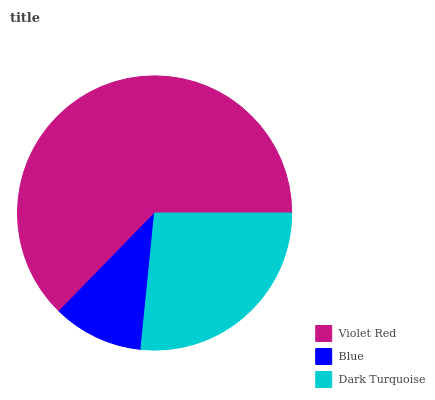Is Blue the minimum?
Answer yes or no. Yes. Is Violet Red the maximum?
Answer yes or no. Yes. Is Dark Turquoise the minimum?
Answer yes or no. No. Is Dark Turquoise the maximum?
Answer yes or no. No. Is Dark Turquoise greater than Blue?
Answer yes or no. Yes. Is Blue less than Dark Turquoise?
Answer yes or no. Yes. Is Blue greater than Dark Turquoise?
Answer yes or no. No. Is Dark Turquoise less than Blue?
Answer yes or no. No. Is Dark Turquoise the high median?
Answer yes or no. Yes. Is Dark Turquoise the low median?
Answer yes or no. Yes. Is Blue the high median?
Answer yes or no. No. Is Blue the low median?
Answer yes or no. No. 